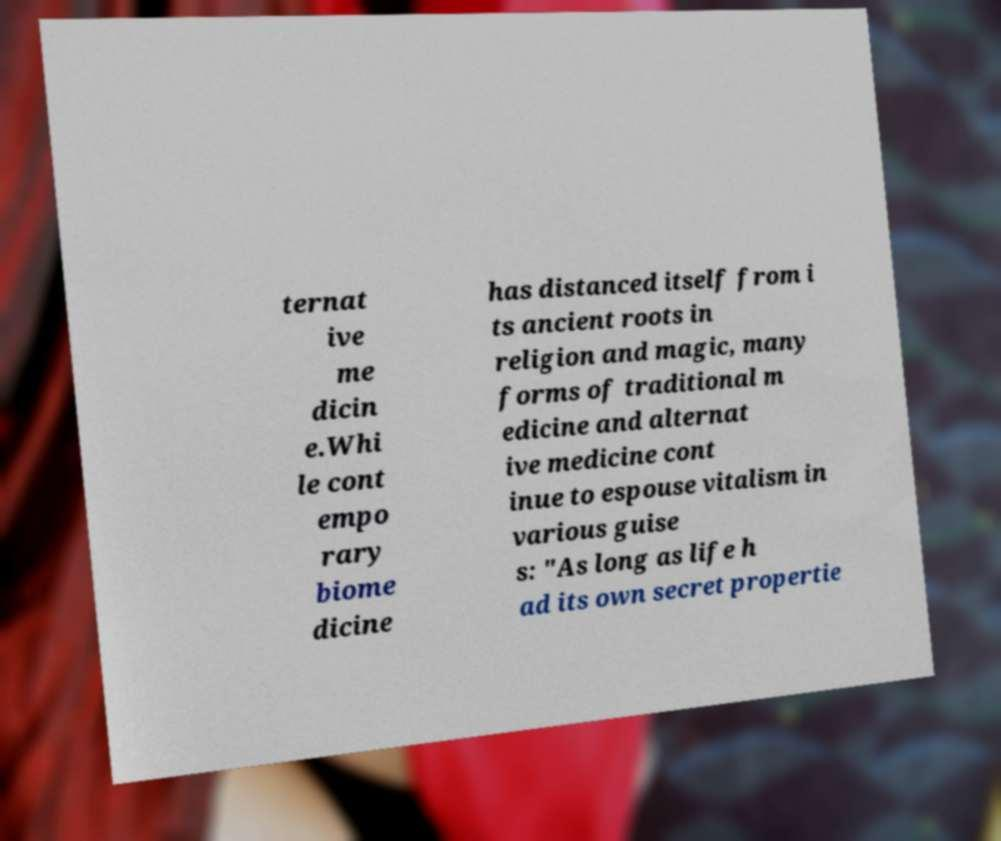What messages or text are displayed in this image? I need them in a readable, typed format. ternat ive me dicin e.Whi le cont empo rary biome dicine has distanced itself from i ts ancient roots in religion and magic, many forms of traditional m edicine and alternat ive medicine cont inue to espouse vitalism in various guise s: "As long as life h ad its own secret propertie 